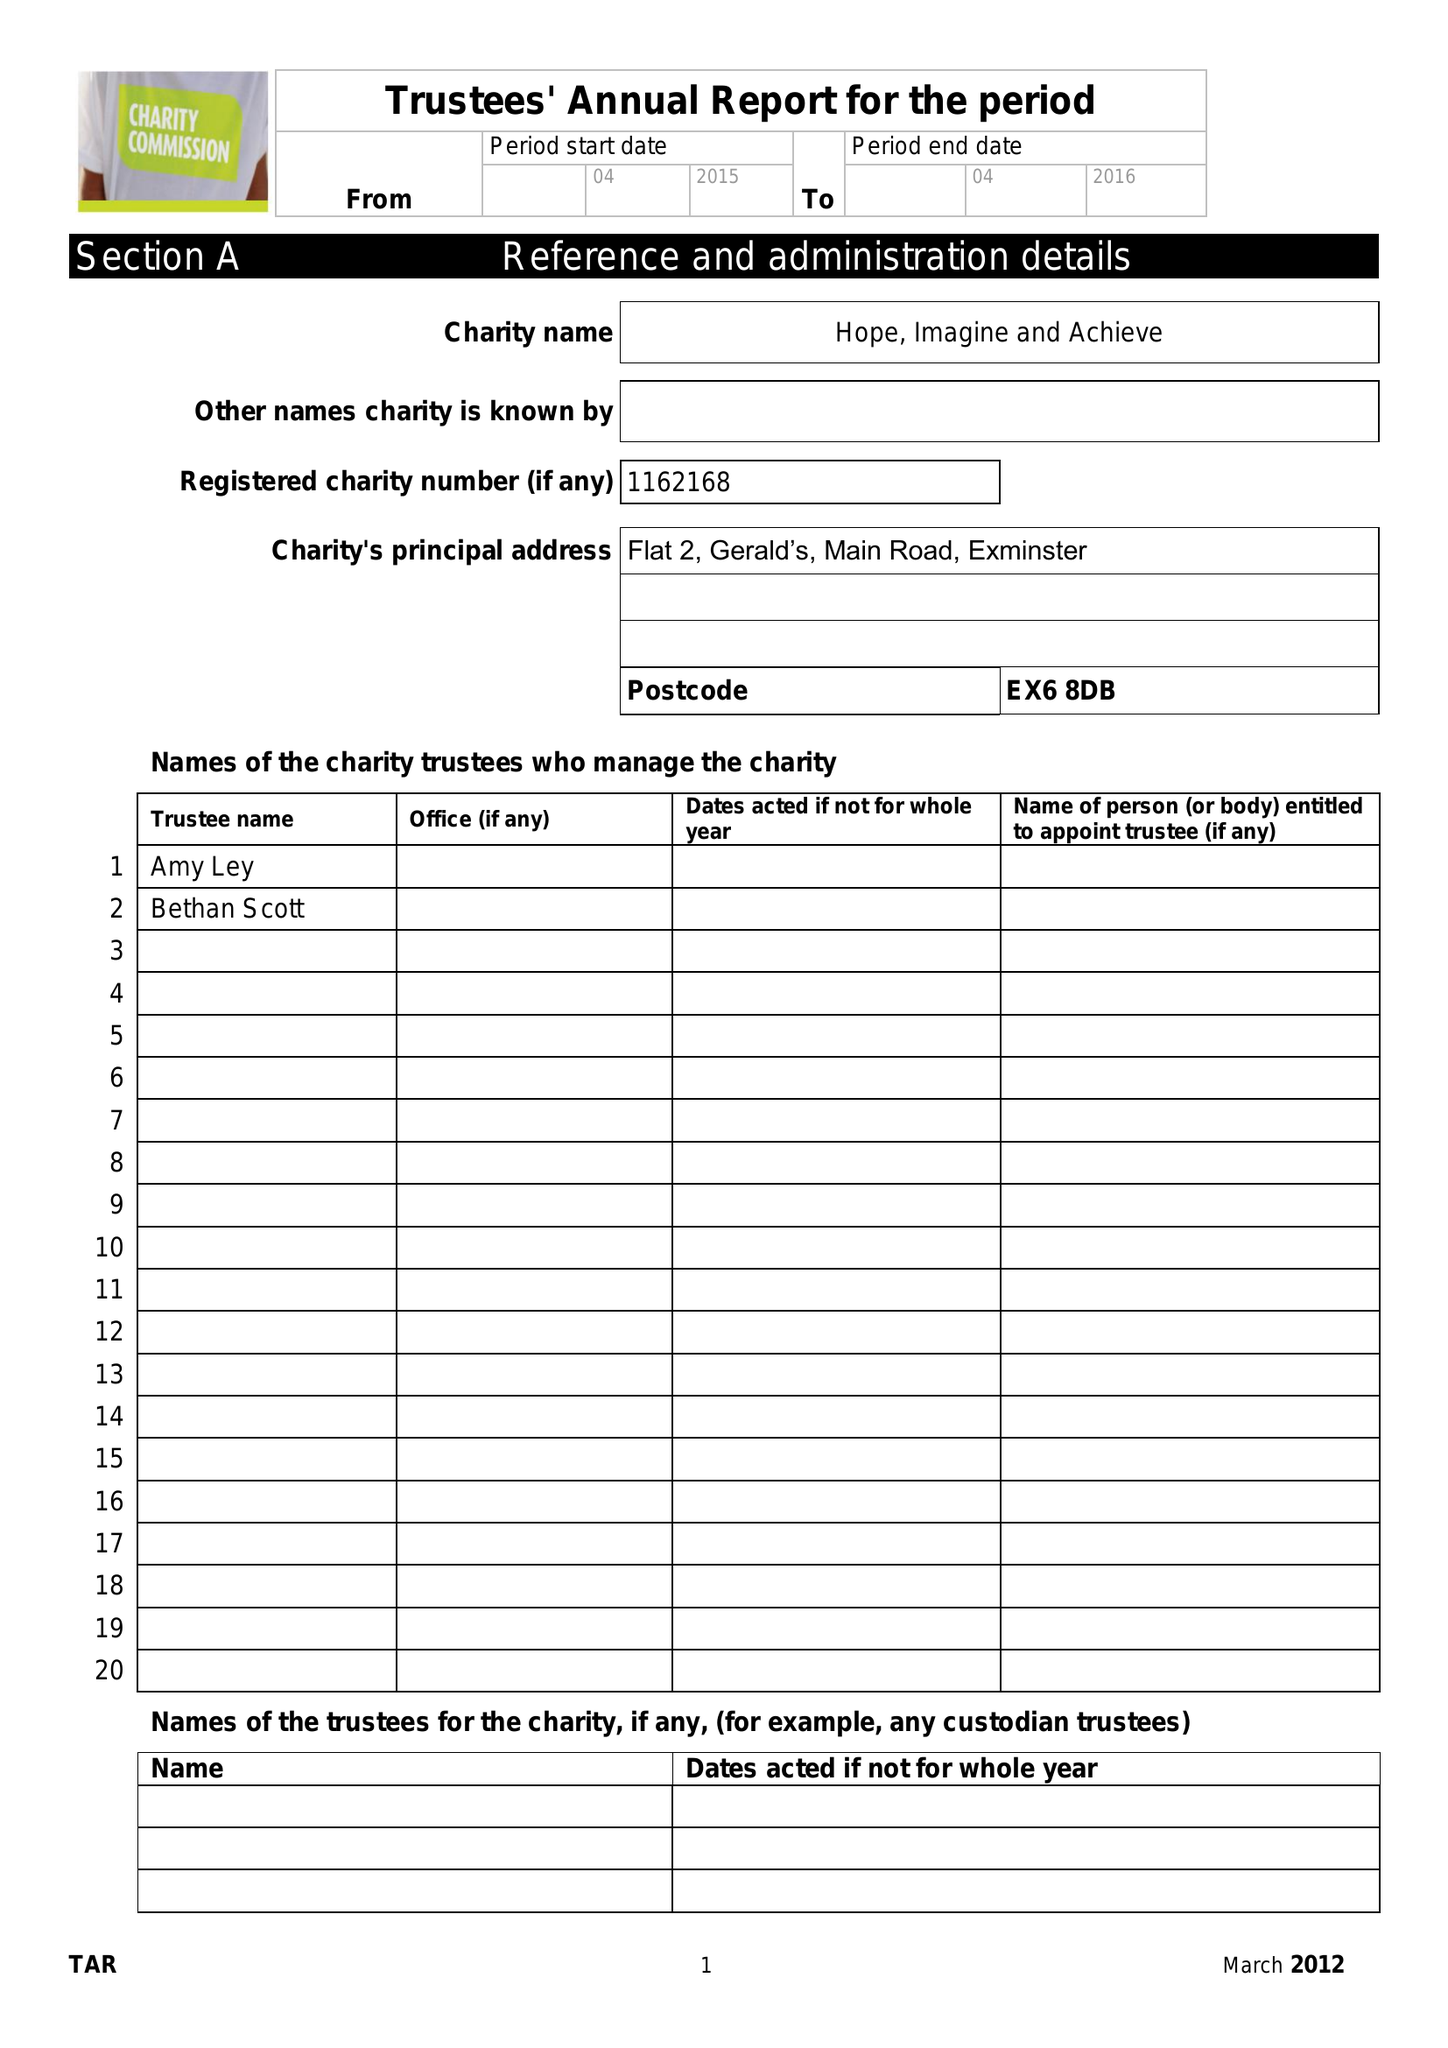What is the value for the address__street_line?
Answer the question using a single word or phrase. None 